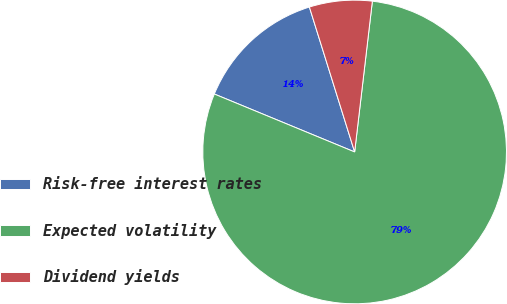Convert chart to OTSL. <chart><loc_0><loc_0><loc_500><loc_500><pie_chart><fcel>Risk-free interest rates<fcel>Expected volatility<fcel>Dividend yields<nl><fcel>13.95%<fcel>79.37%<fcel>6.68%<nl></chart> 